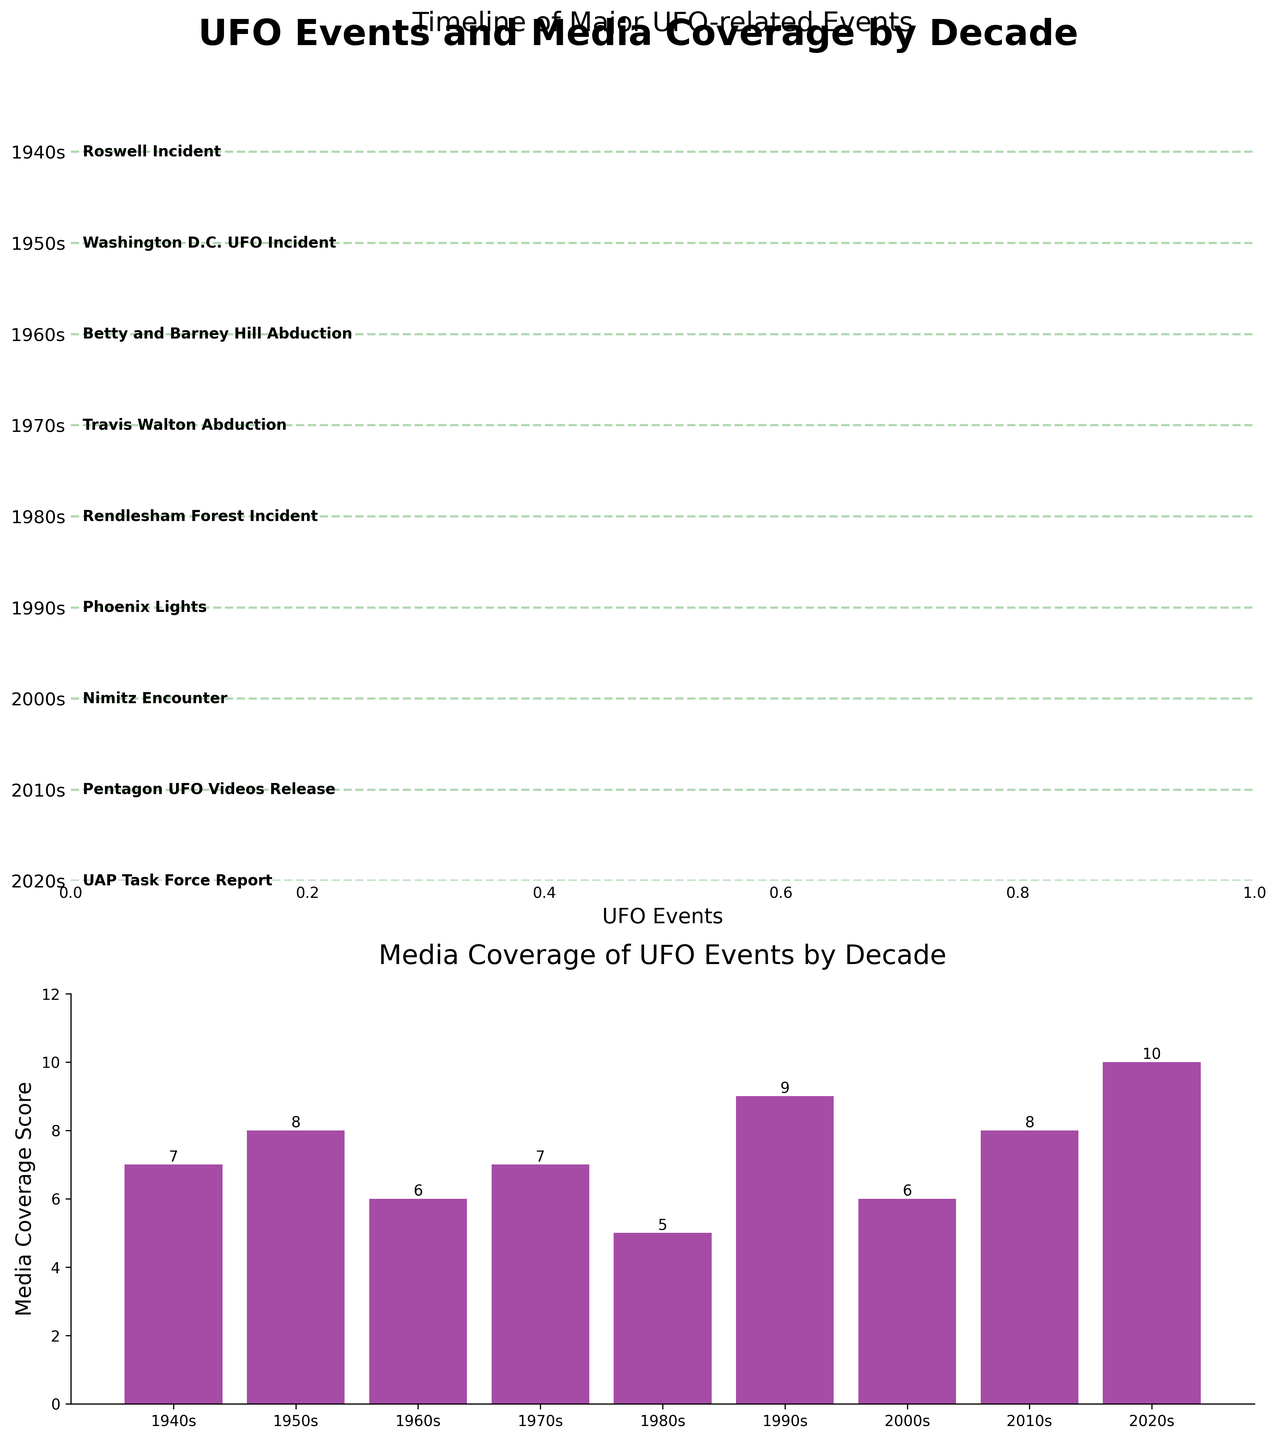What major UFO event happened in the 1980s? On the timeline in the first subplot, you can see that the major UFO event listed for the 1980s is the Rendlesham Forest Incident.
Answer: Rendlesham Forest Incident How many decades had a Media Coverage Score of 7? Looking at the bars in the second subplot, we see three bars reaching a height of 7: one in the 1940s, one in the 1970s, and one in the 2000s.
Answer: 3 Which decade had the highest Media Coverage Score? By examining the heights of the bars in the second subplot, the highest bar corresponds to the 2020s with a score of 10.
Answer: 2020s Which major UFO event is associated with the highest Media Coverage Score? The associated UFO event can be found under the bar with the highest score in the second subplot. The 2020s had the highest score, and as referenced in the first subplot, the event is the UAP Task Force Report.
Answer: UAP Task Force Report How does the Media Coverage Score of the Phoenix Lights compare to the Nimitz Encounter? The Phoenix Lights (1990s) has a Media Coverage Score of 9, while the Nimitz Encounter (2000s) has a score of 6.
Answer: The Phoenix Lights had a higher score than the Nimitz Encounter What decade is represented between the 1960s and the 1980s on the timeline? In the first subplot, the timeline shows the 1970s between the 1960s and the 1980s.
Answer: 1970s Which UFO event has the lowest Media Coverage Score, and what is the score? By examining the height of the bars and the corresponding events, the Rendlesham Forest Incident from the 1980s has the lowest score of 5.
Answer: Rendlesham Forest Incident, 5 What is the average Media Coverage Score across all decades? To find the average, add all the Media Coverage Scores (7, 8, 6, 7, 5, 9, 6, 8, 10) and divide by the number of decades (9). The sum is 66, so the average is 66/9.
Answer: 7.33 What is the Media Coverage Score for the Betty and Barney Hill Abduction? The Betty and Barney Hill Abduction occurred in the 1960s. The corresponding bar in the second subplot shows a Media Coverage Score of 6.
Answer: 6 